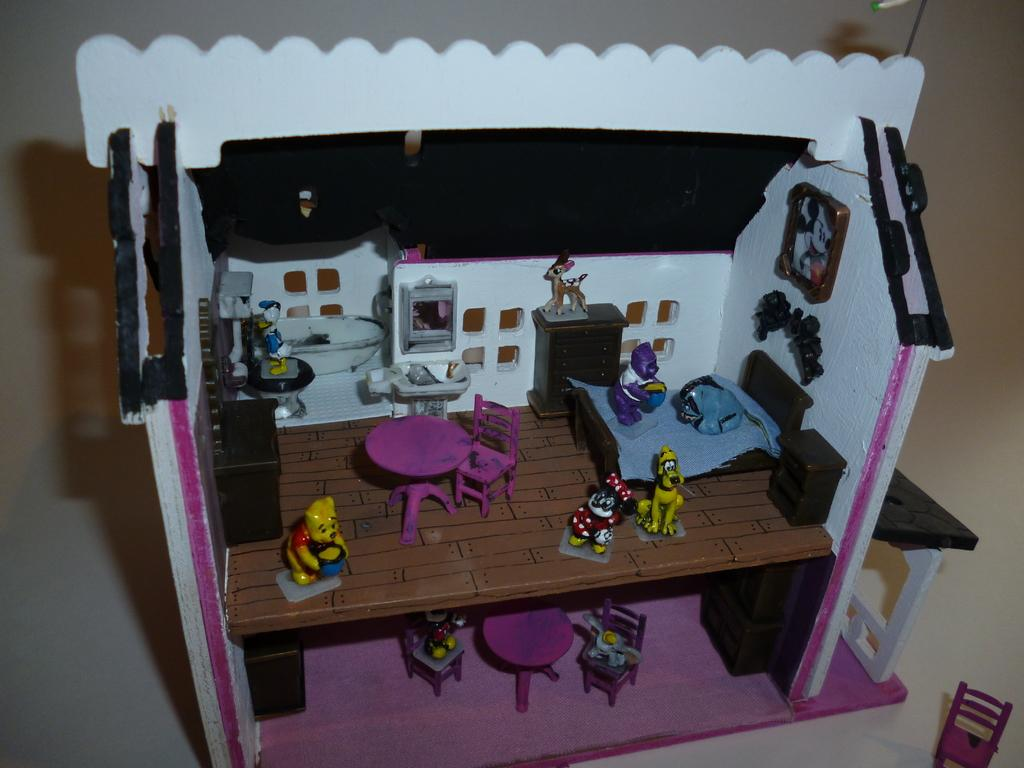What type of structure is visible in the picture? There is a house in the picture. What items can be found inside the house? There are toys, a bed, a chair, and a table inside the house. Who is the creator of the suit that is hanging on the chair in the image? There is no suit hanging on the chair in the image; only a chair is mentioned. 